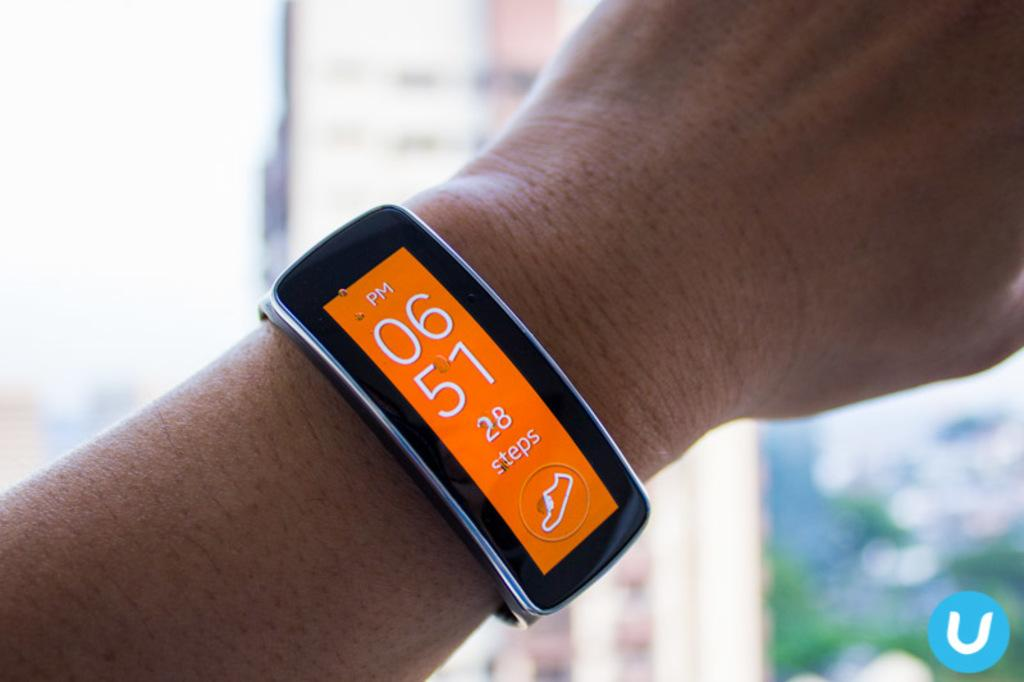Provide a one-sentence caption for the provided image. Person wearing a wristwatch which says 0651 on it. 